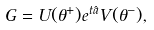Convert formula to latex. <formula><loc_0><loc_0><loc_500><loc_500>G = U ( \theta ^ { + } ) e ^ { t \hat { a } } V ( \theta ^ { - } ) ,</formula> 